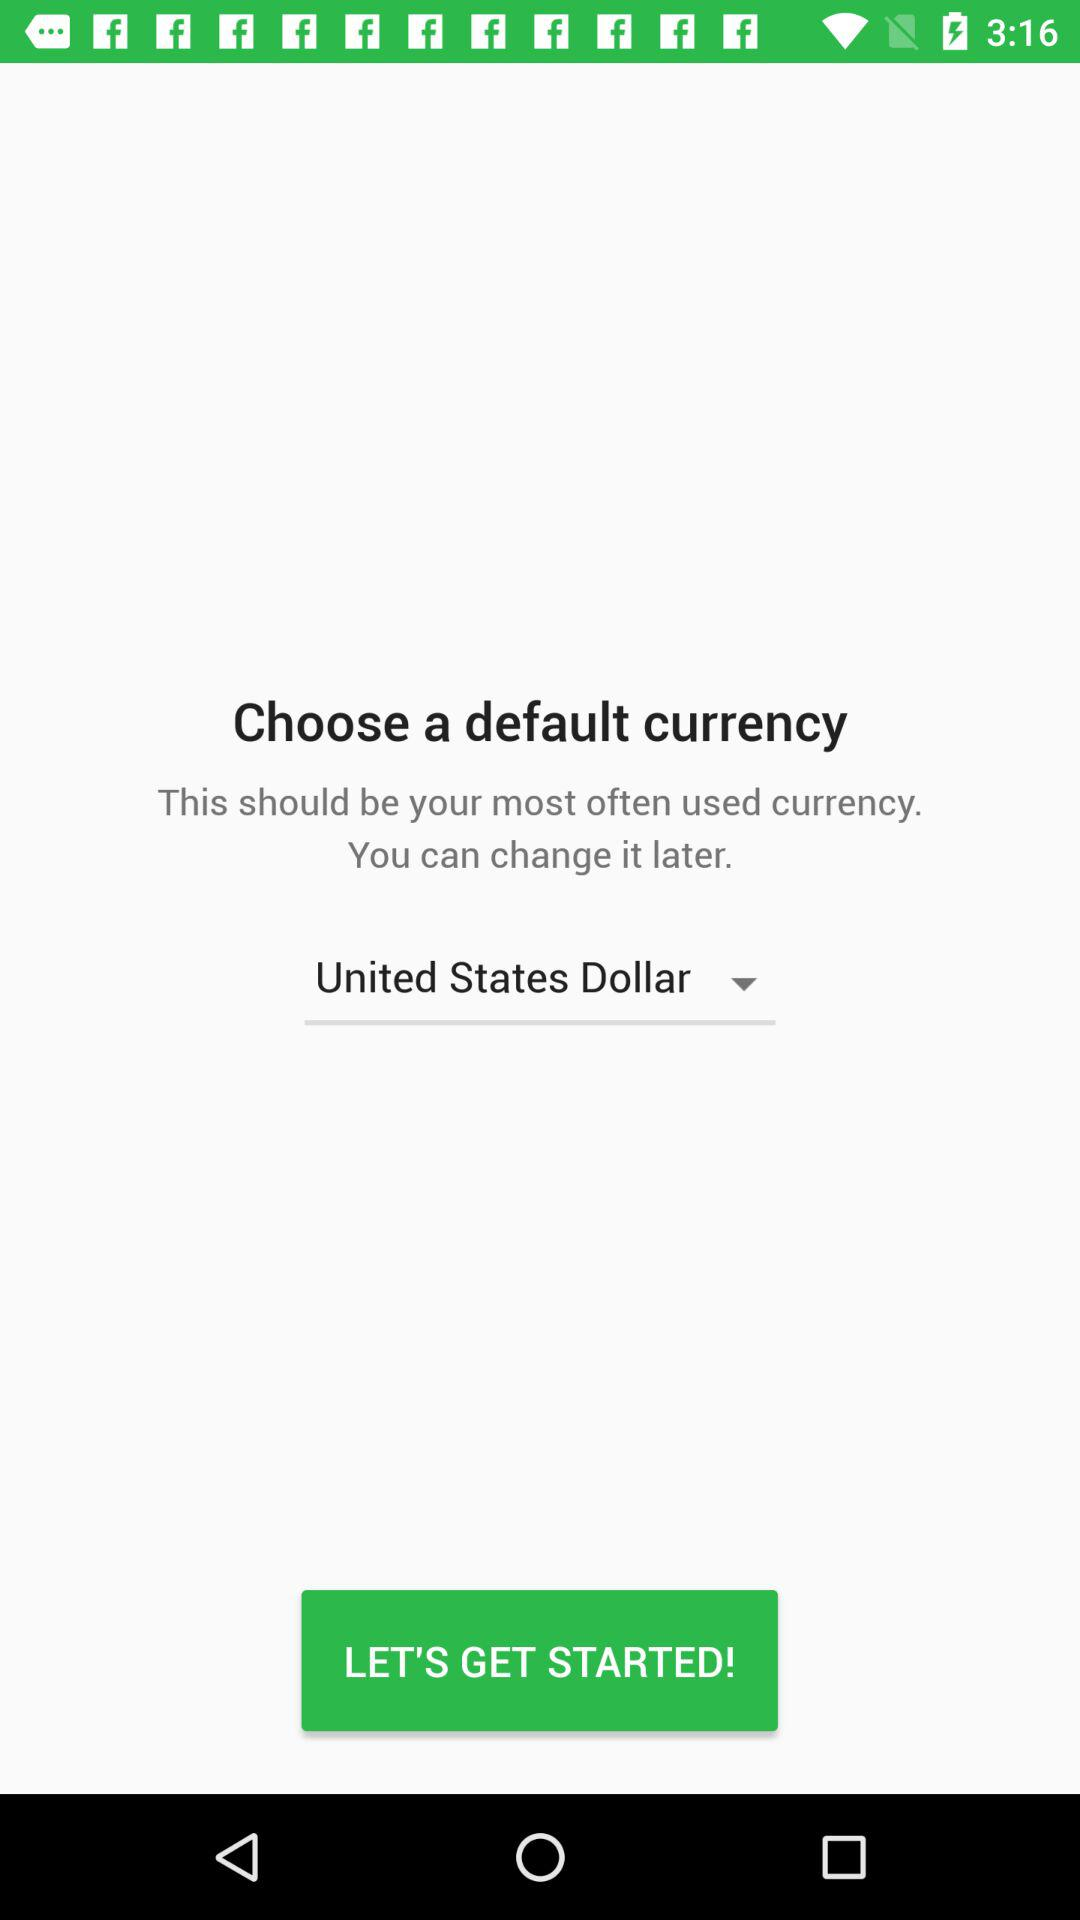What is the selected currency? The selected currency is United States Dollar. 